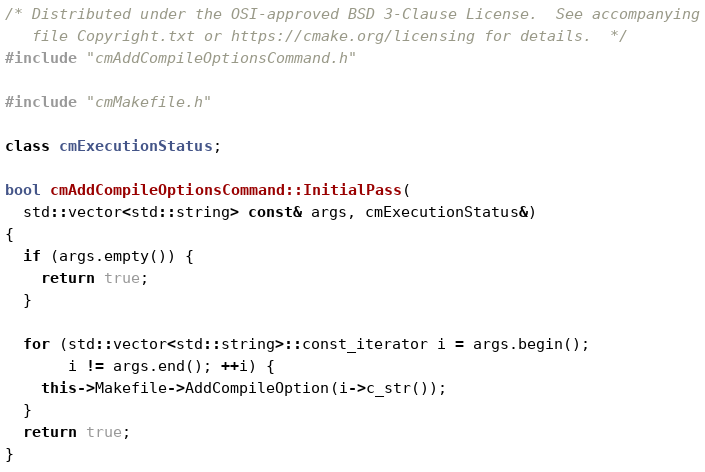<code> <loc_0><loc_0><loc_500><loc_500><_C++_>/* Distributed under the OSI-approved BSD 3-Clause License.  See accompanying
   file Copyright.txt or https://cmake.org/licensing for details.  */
#include "cmAddCompileOptionsCommand.h"

#include "cmMakefile.h"

class cmExecutionStatus;

bool cmAddCompileOptionsCommand::InitialPass(
  std::vector<std::string> const& args, cmExecutionStatus&)
{
  if (args.empty()) {
    return true;
  }

  for (std::vector<std::string>::const_iterator i = args.begin();
       i != args.end(); ++i) {
    this->Makefile->AddCompileOption(i->c_str());
  }
  return true;
}
</code> 